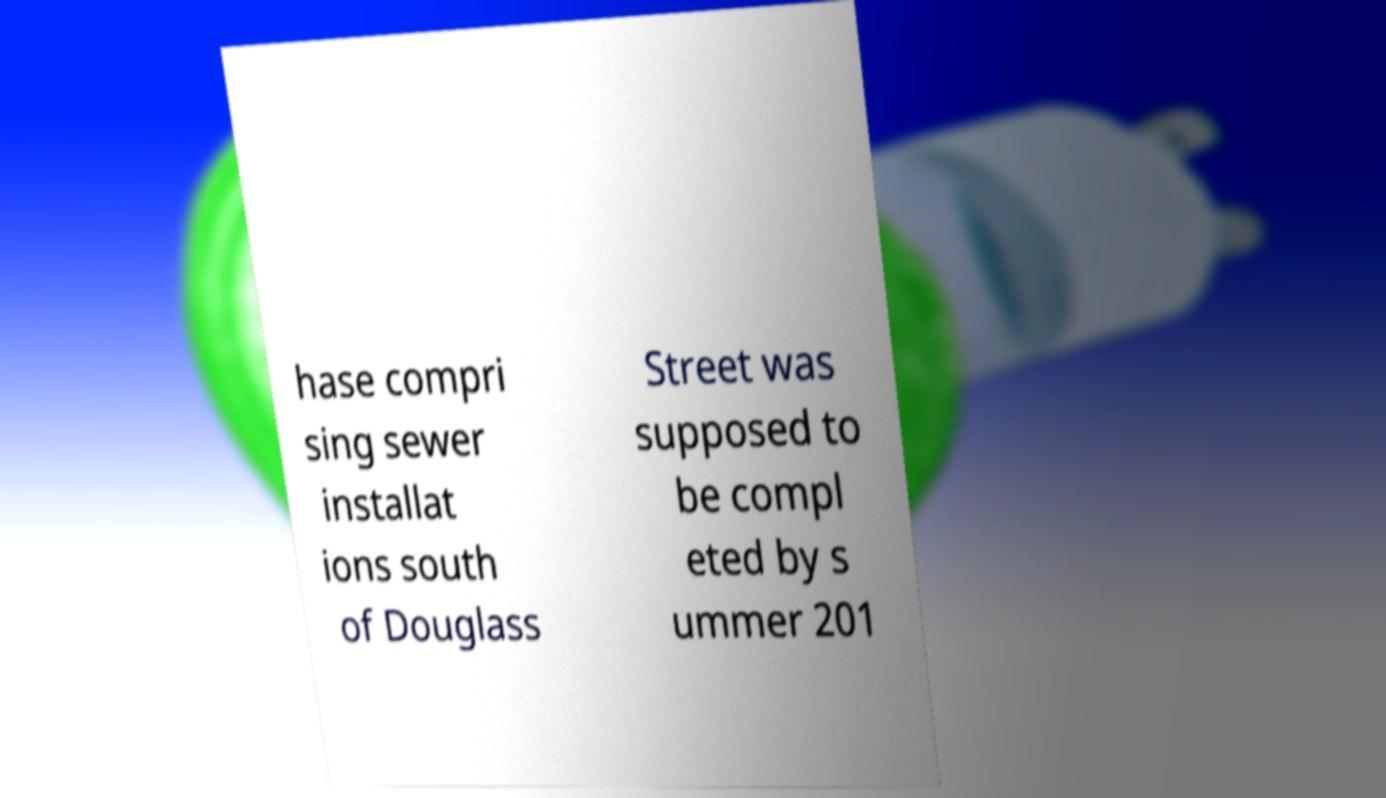There's text embedded in this image that I need extracted. Can you transcribe it verbatim? hase compri sing sewer installat ions south of Douglass Street was supposed to be compl eted by s ummer 201 